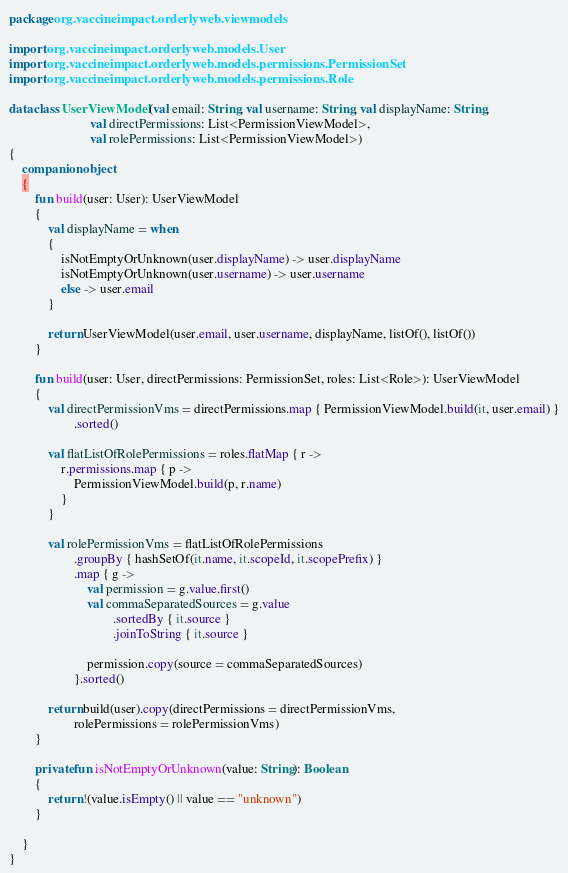Convert code to text. <code><loc_0><loc_0><loc_500><loc_500><_Kotlin_>package org.vaccineimpact.orderlyweb.viewmodels

import org.vaccineimpact.orderlyweb.models.User
import org.vaccineimpact.orderlyweb.models.permissions.PermissionSet
import org.vaccineimpact.orderlyweb.models.permissions.Role

data class UserViewModel(val email: String, val username: String, val displayName: String,
                         val directPermissions: List<PermissionViewModel>,
                         val rolePermissions: List<PermissionViewModel>)
{
    companion object
    {
        fun build(user: User): UserViewModel
        {
            val displayName = when
            {
                isNotEmptyOrUnknown(user.displayName) -> user.displayName
                isNotEmptyOrUnknown(user.username) -> user.username
                else -> user.email
            }

            return UserViewModel(user.email, user.username, displayName, listOf(), listOf())
        }

        fun build(user: User, directPermissions: PermissionSet, roles: List<Role>): UserViewModel
        {
            val directPermissionVms = directPermissions.map { PermissionViewModel.build(it, user.email) }
                    .sorted()

            val flatListOfRolePermissions = roles.flatMap { r ->
                r.permissions.map { p ->
                    PermissionViewModel.build(p, r.name)
                }
            }

            val rolePermissionVms = flatListOfRolePermissions
                    .groupBy { hashSetOf(it.name, it.scopeId, it.scopePrefix) }
                    .map { g ->
                        val permission = g.value.first()
                        val commaSeparatedSources = g.value
                                .sortedBy { it.source }
                                .joinToString { it.source }

                        permission.copy(source = commaSeparatedSources)
                    }.sorted()

            return build(user).copy(directPermissions = directPermissionVms,
                    rolePermissions = rolePermissionVms)
        }

        private fun isNotEmptyOrUnknown(value: String): Boolean
        {
            return !(value.isEmpty() || value == "unknown")
        }

    }
}</code> 